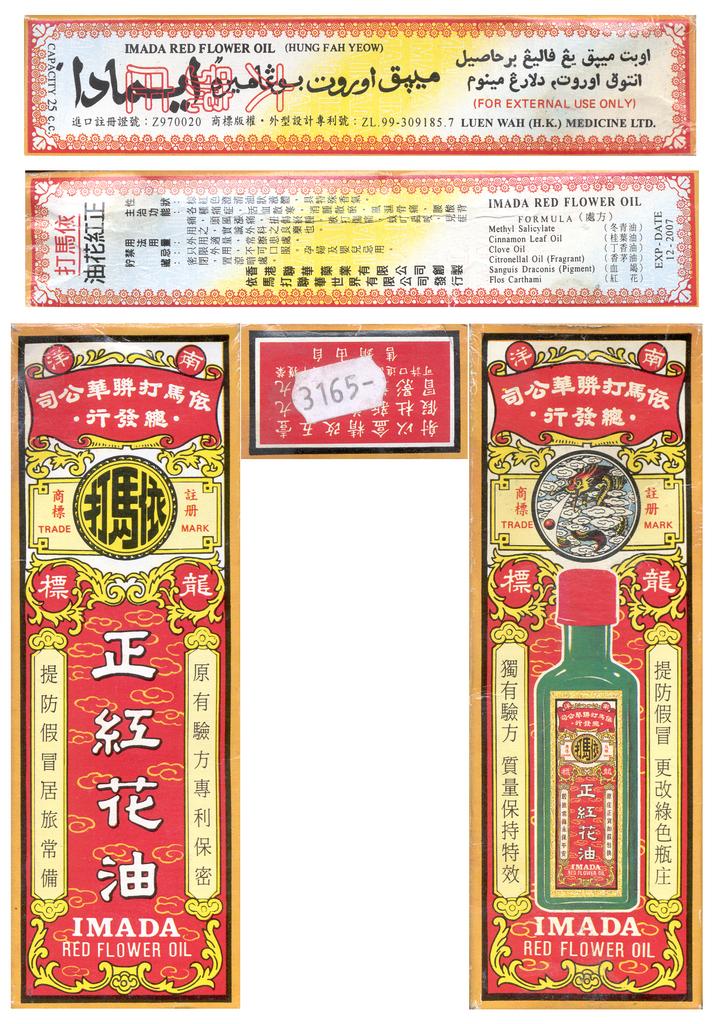What type of oil is this?
Offer a very short reply. Red flower oil. 